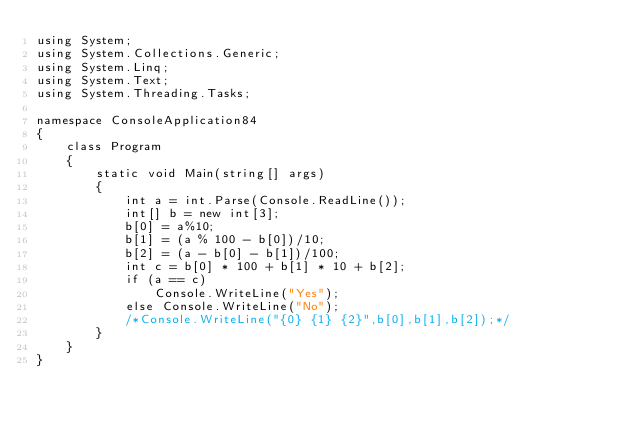<code> <loc_0><loc_0><loc_500><loc_500><_C#_>using System;
using System.Collections.Generic;
using System.Linq;
using System.Text;
using System.Threading.Tasks;

namespace ConsoleApplication84
{
    class Program
    {
        static void Main(string[] args)
        {
            int a = int.Parse(Console.ReadLine());
            int[] b = new int[3];
            b[0] = a%10;
            b[1] = (a % 100 - b[0])/10;
            b[2] = (a - b[0] - b[1])/100;
            int c = b[0] * 100 + b[1] * 10 + b[2];
            if (a == c)
                Console.WriteLine("Yes");
            else Console.WriteLine("No");
            /*Console.WriteLine("{0} {1} {2}",b[0],b[1],b[2]);*/
        }
    }
}
</code> 